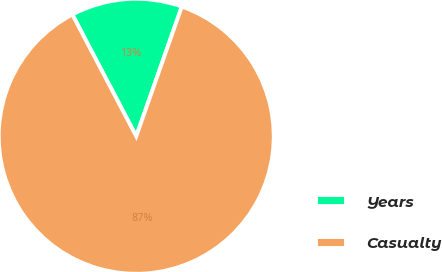<chart> <loc_0><loc_0><loc_500><loc_500><pie_chart><fcel>Years<fcel>Casualty<nl><fcel>13.07%<fcel>86.93%<nl></chart> 